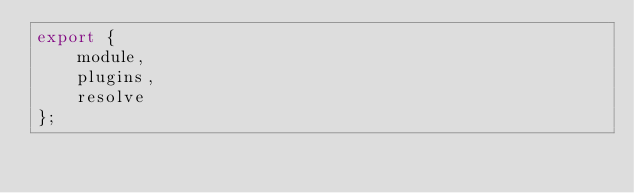Convert code to text. <code><loc_0><loc_0><loc_500><loc_500><_JavaScript_>export {
    module,
    plugins,
    resolve
};
</code> 